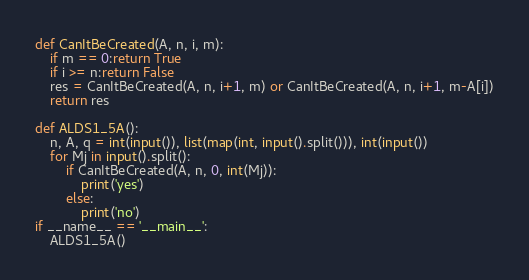Convert code to text. <code><loc_0><loc_0><loc_500><loc_500><_Python_>def CanItBeCreated(A, n, i, m):
    if m == 0:return True
    if i >= n:return False
    res = CanItBeCreated(A, n, i+1, m) or CanItBeCreated(A, n, i+1, m-A[i])
    return res

def ALDS1_5A():
    n, A, q = int(input()), list(map(int, input().split())), int(input())
    for Mj in input().split():
        if CanItBeCreated(A, n, 0, int(Mj)):
            print('yes')
        else:
            print('no')
if __name__ == '__main__':
    ALDS1_5A()</code> 